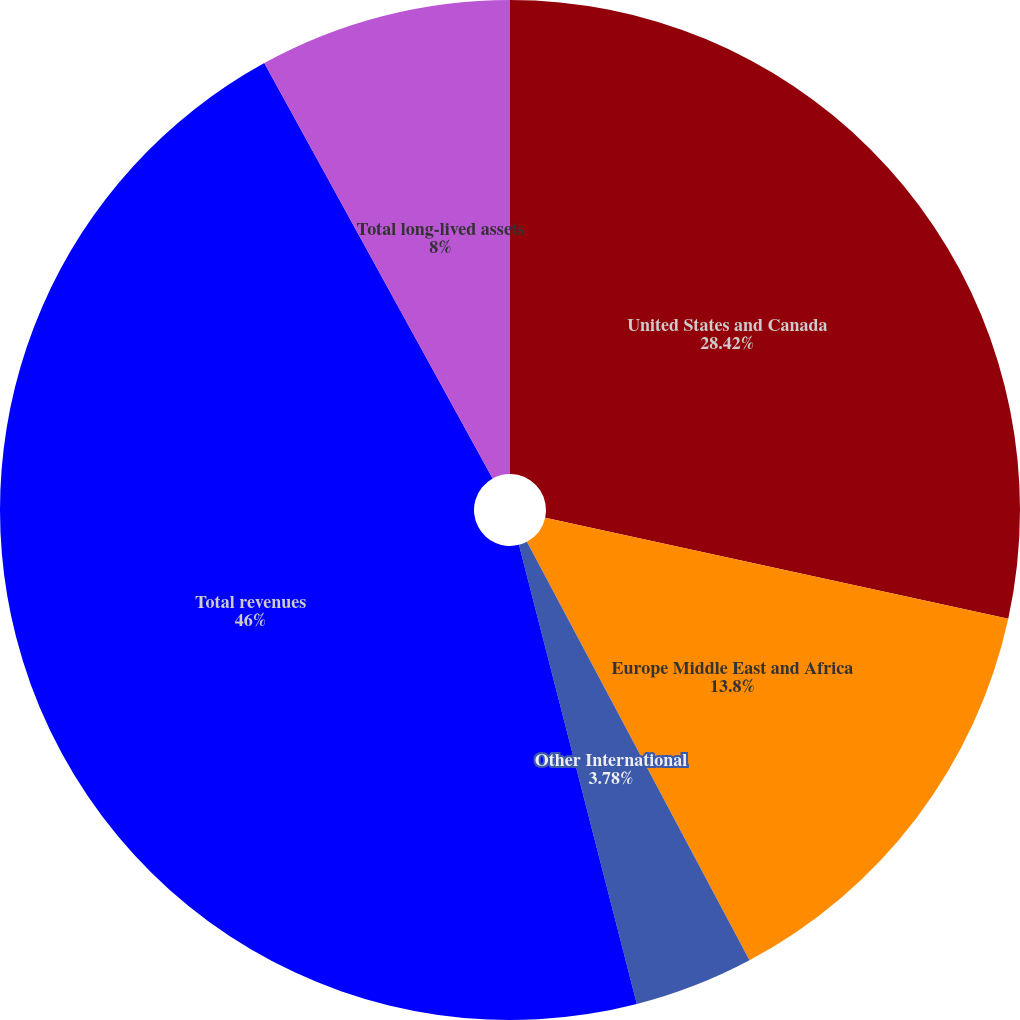Convert chart to OTSL. <chart><loc_0><loc_0><loc_500><loc_500><pie_chart><fcel>United States and Canada<fcel>Europe Middle East and Africa<fcel>Other International<fcel>Total revenues<fcel>Total long-lived assets<nl><fcel>28.42%<fcel>13.8%<fcel>3.78%<fcel>46.0%<fcel>8.0%<nl></chart> 